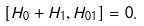Convert formula to latex. <formula><loc_0><loc_0><loc_500><loc_500>\left [ { H _ { 0 } + H _ { 1 } , H _ { 0 1 } } \right ] = 0 .</formula> 